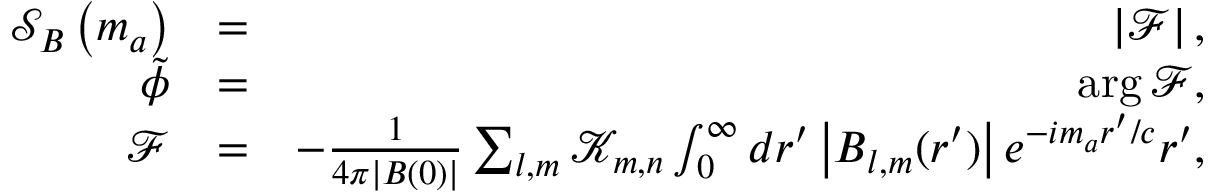Convert formula to latex. <formula><loc_0><loc_0><loc_500><loc_500>\begin{array} { r l r } { \mathcal { S } _ { B } \left ( m _ { a } \right ) } & { = } & { \left | \mathcal { F } \right | , } \\ { \tilde { \phi } } & { = } & { \arg \mathcal { F } , } \\ { \mathcal { F } } & { = } & { - \frac { 1 } { 4 \pi \left | { \boldsymbol B } ( 0 ) \right | } \sum _ { l , m } \mathcal { K } _ { m , n } \int _ { 0 } ^ { \infty } d r ^ { \prime } \left | \boldsymbol B _ { l , m } ( r ^ { \prime } ) \right | e ^ { - i m _ { a } r ^ { \prime } / c } r ^ { \prime } , } \end{array}</formula> 